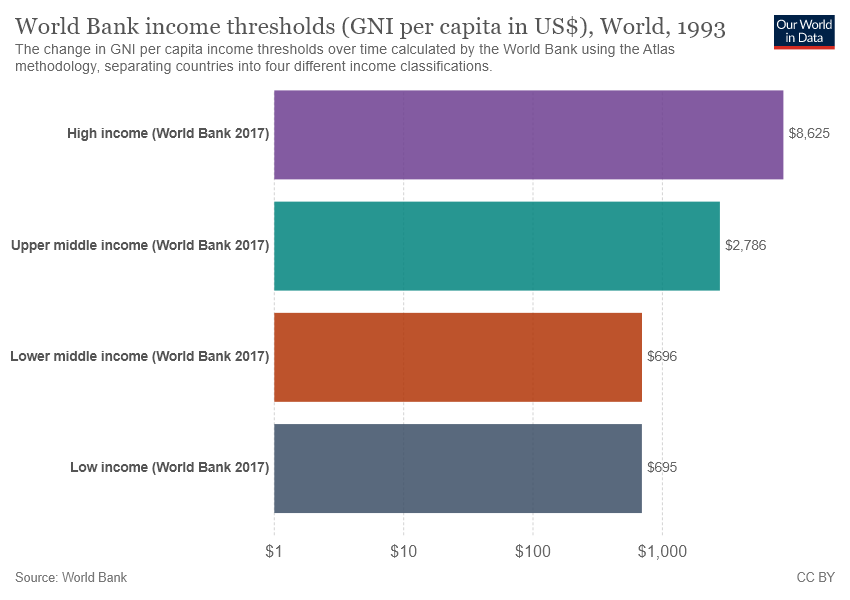List a handful of essential elements in this visual. According to the World Bank's 2017 classification, the income bracket with the highest value is high income. The average income is $3,200.50. 